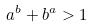<formula> <loc_0><loc_0><loc_500><loc_500>a ^ { b } + b ^ { a } > 1</formula> 